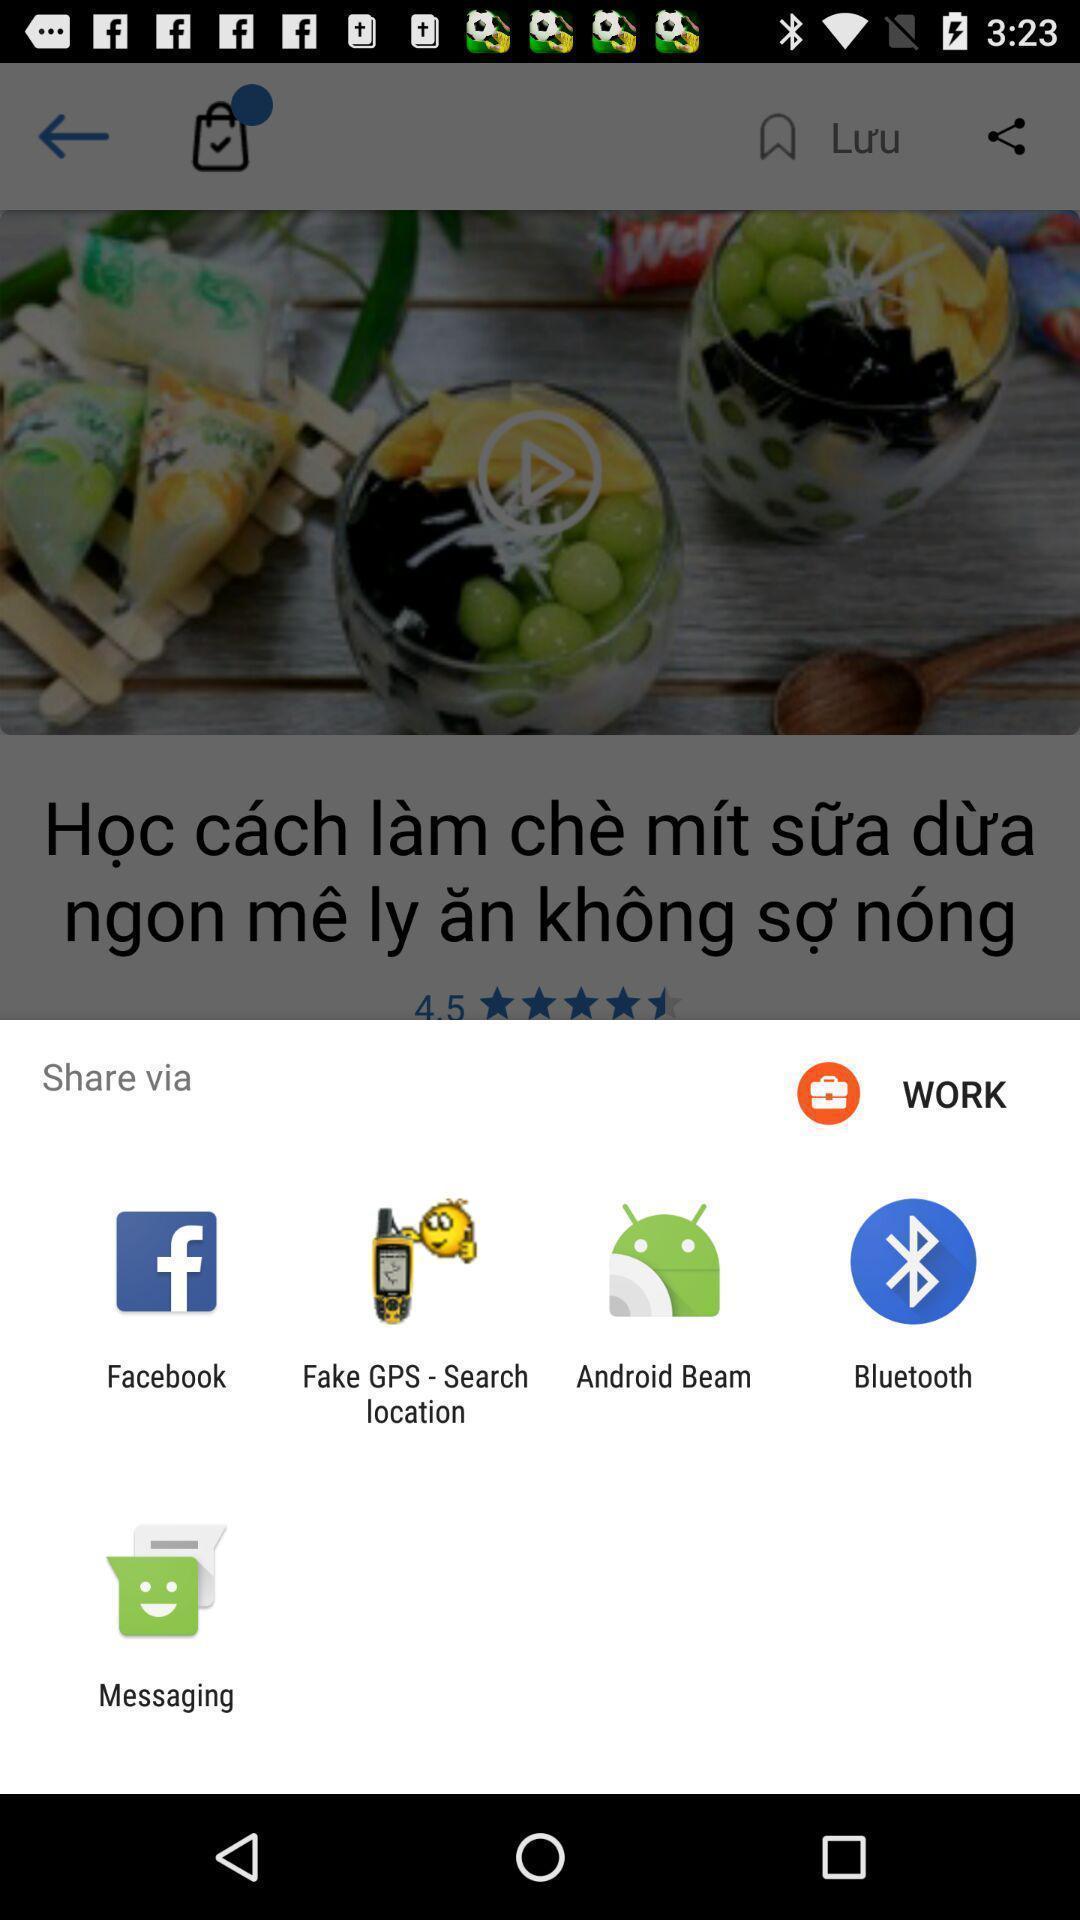Provide a description of this screenshot. Pop-up to share recipe via different apps. 